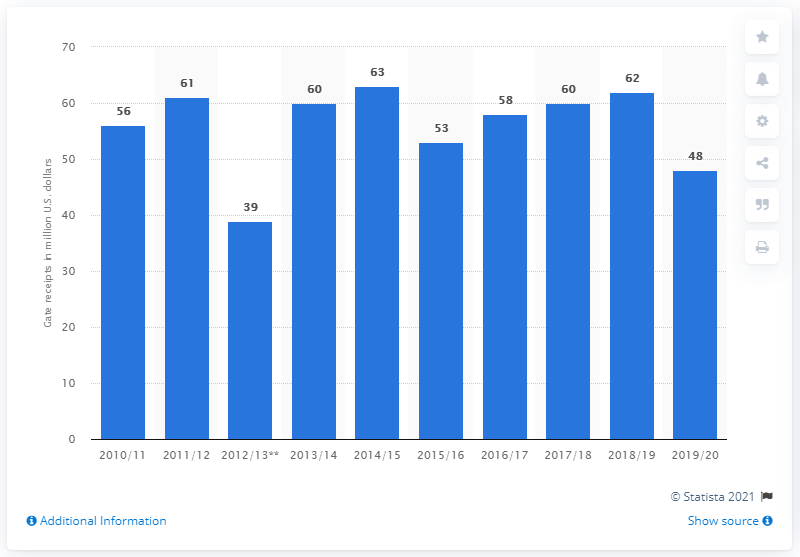Highlight a few significant elements in this photo. The Calgary Flames' gate receipts for the 2019/20 season were $48 million. 